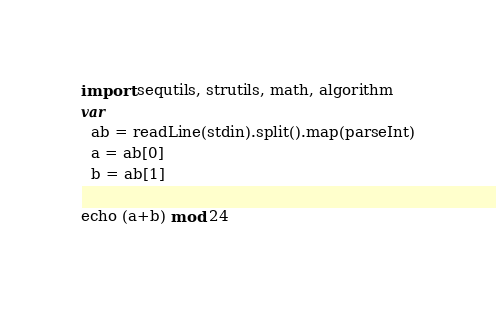Convert code to text. <code><loc_0><loc_0><loc_500><loc_500><_Nim_>import sequtils, strutils, math, algorithm
var
  ab = readLine(stdin).split().map(parseInt)
  a = ab[0]
  b = ab[1]

echo (a+b) mod 24</code> 